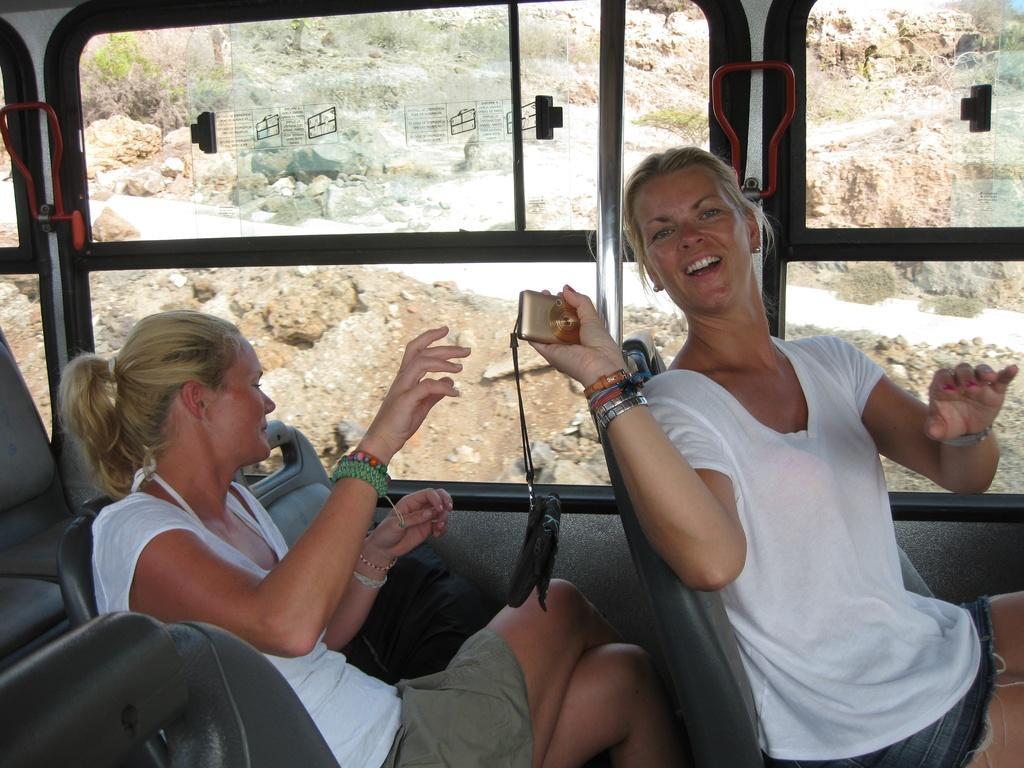Can you describe this image briefly? In this image on the right there is a woman, she wears a t shirt, trouser, she is holding a camera, behind her there is a woman, she wears a t shirt, trouser, her hair is short, they are sitting inside a bus. In the background there are windows, glass, stones and land. 